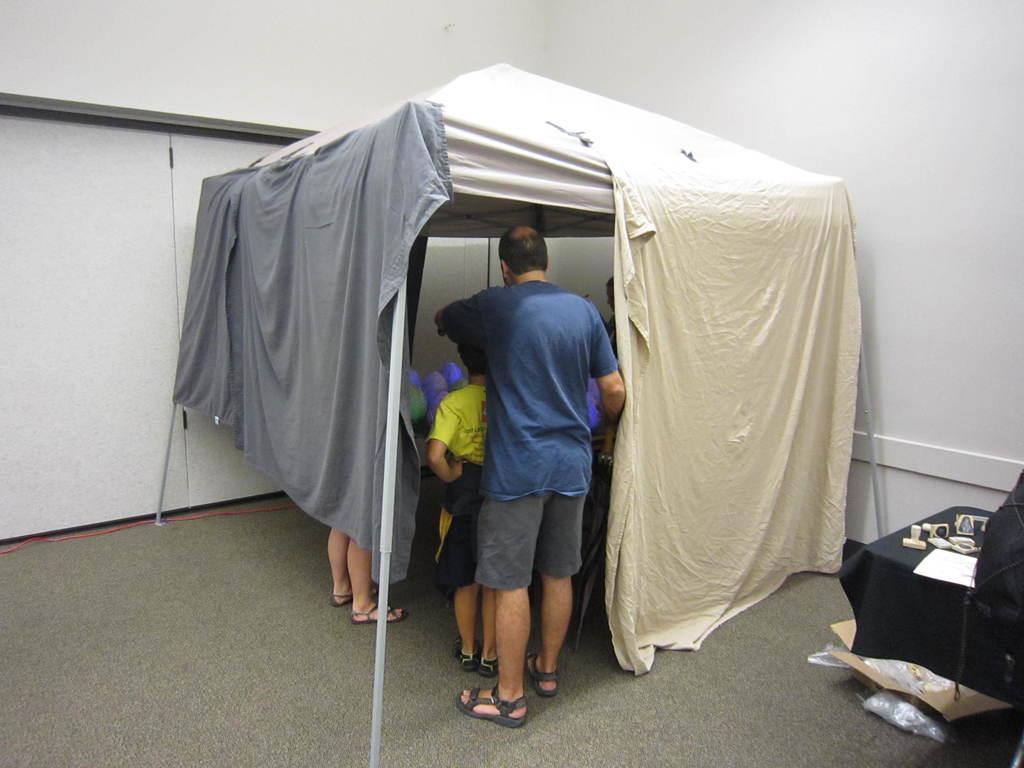In one or two sentences, can you explain what this image depicts? In this picture we can see a tent, in which we can see few people are standing, side we can see the table and some objects. 